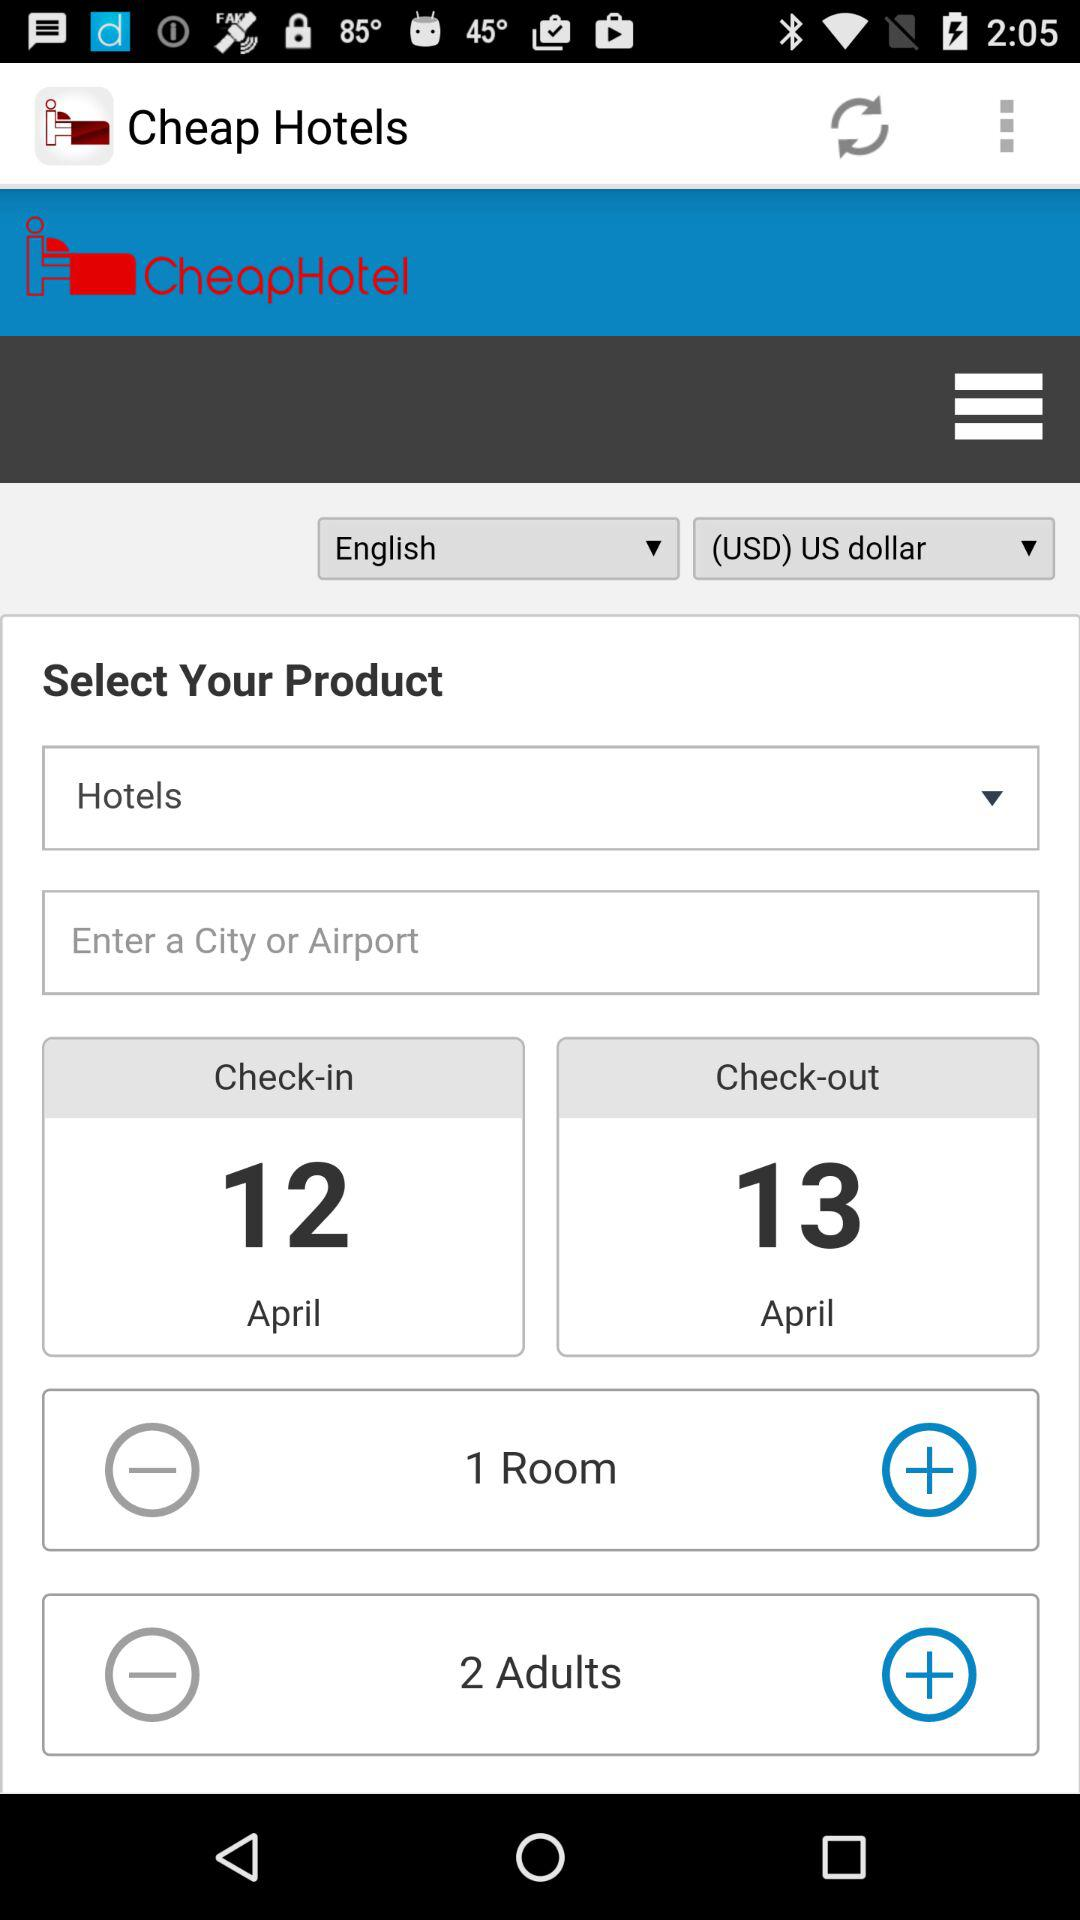For how many people is the hotel booking in progress? The hotel booking is in progress for 2 people. 